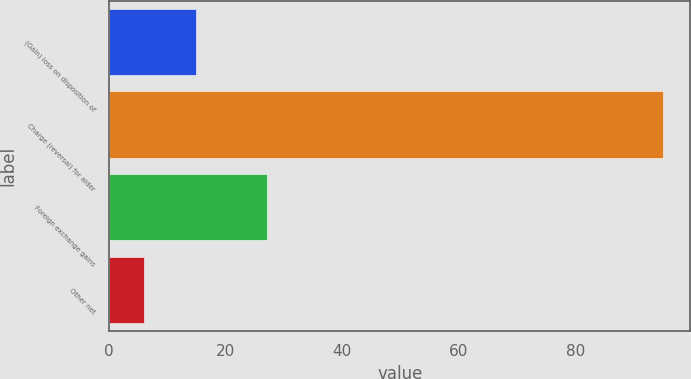Convert chart to OTSL. <chart><loc_0><loc_0><loc_500><loc_500><bar_chart><fcel>(Gain) loss on disposition of<fcel>Charge (reversal) for alder<fcel>Foreign exchange gains<fcel>Other net<nl><fcel>14.9<fcel>95<fcel>27<fcel>6<nl></chart> 